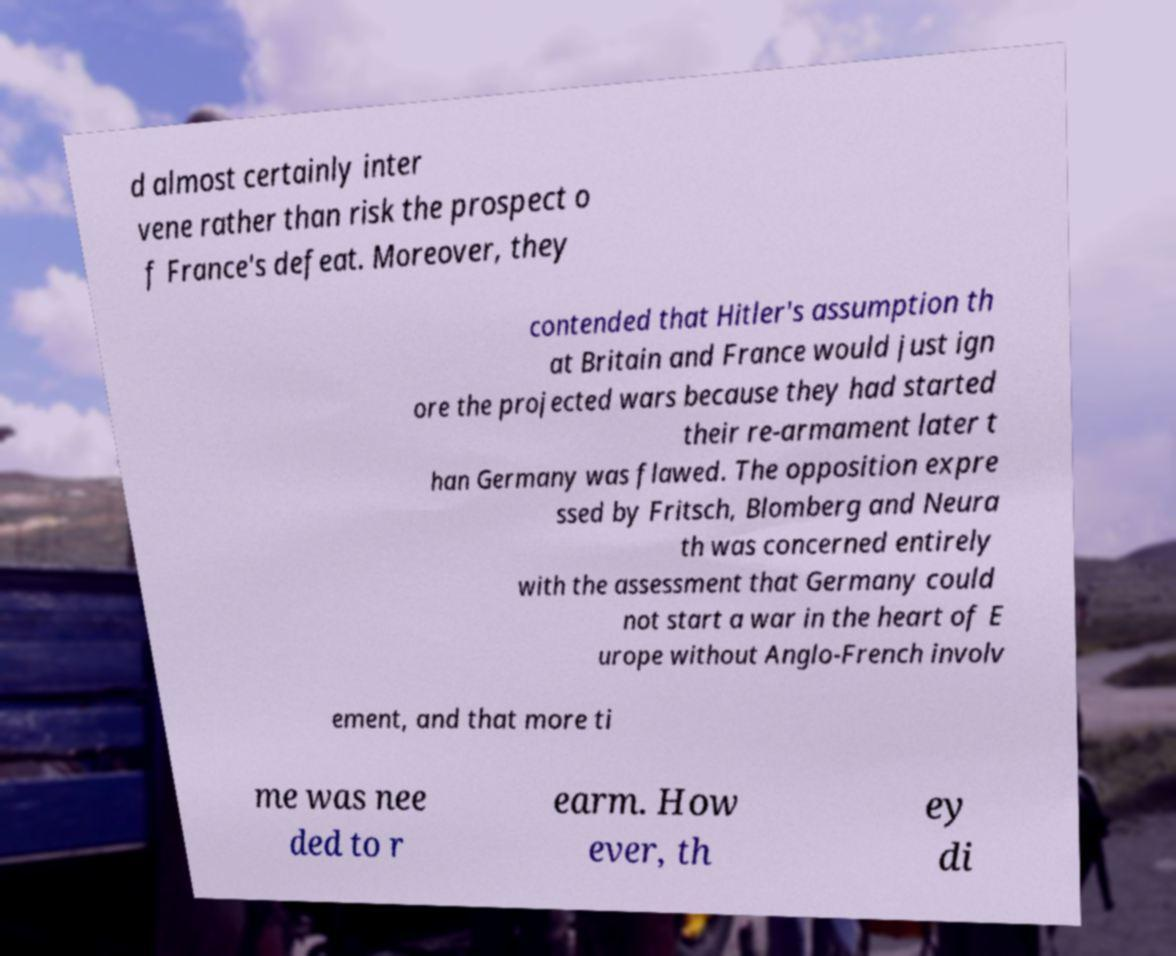Can you read and provide the text displayed in the image?This photo seems to have some interesting text. Can you extract and type it out for me? d almost certainly inter vene rather than risk the prospect o f France's defeat. Moreover, they contended that Hitler's assumption th at Britain and France would just ign ore the projected wars because they had started their re-armament later t han Germany was flawed. The opposition expre ssed by Fritsch, Blomberg and Neura th was concerned entirely with the assessment that Germany could not start a war in the heart of E urope without Anglo-French involv ement, and that more ti me was nee ded to r earm. How ever, th ey di 